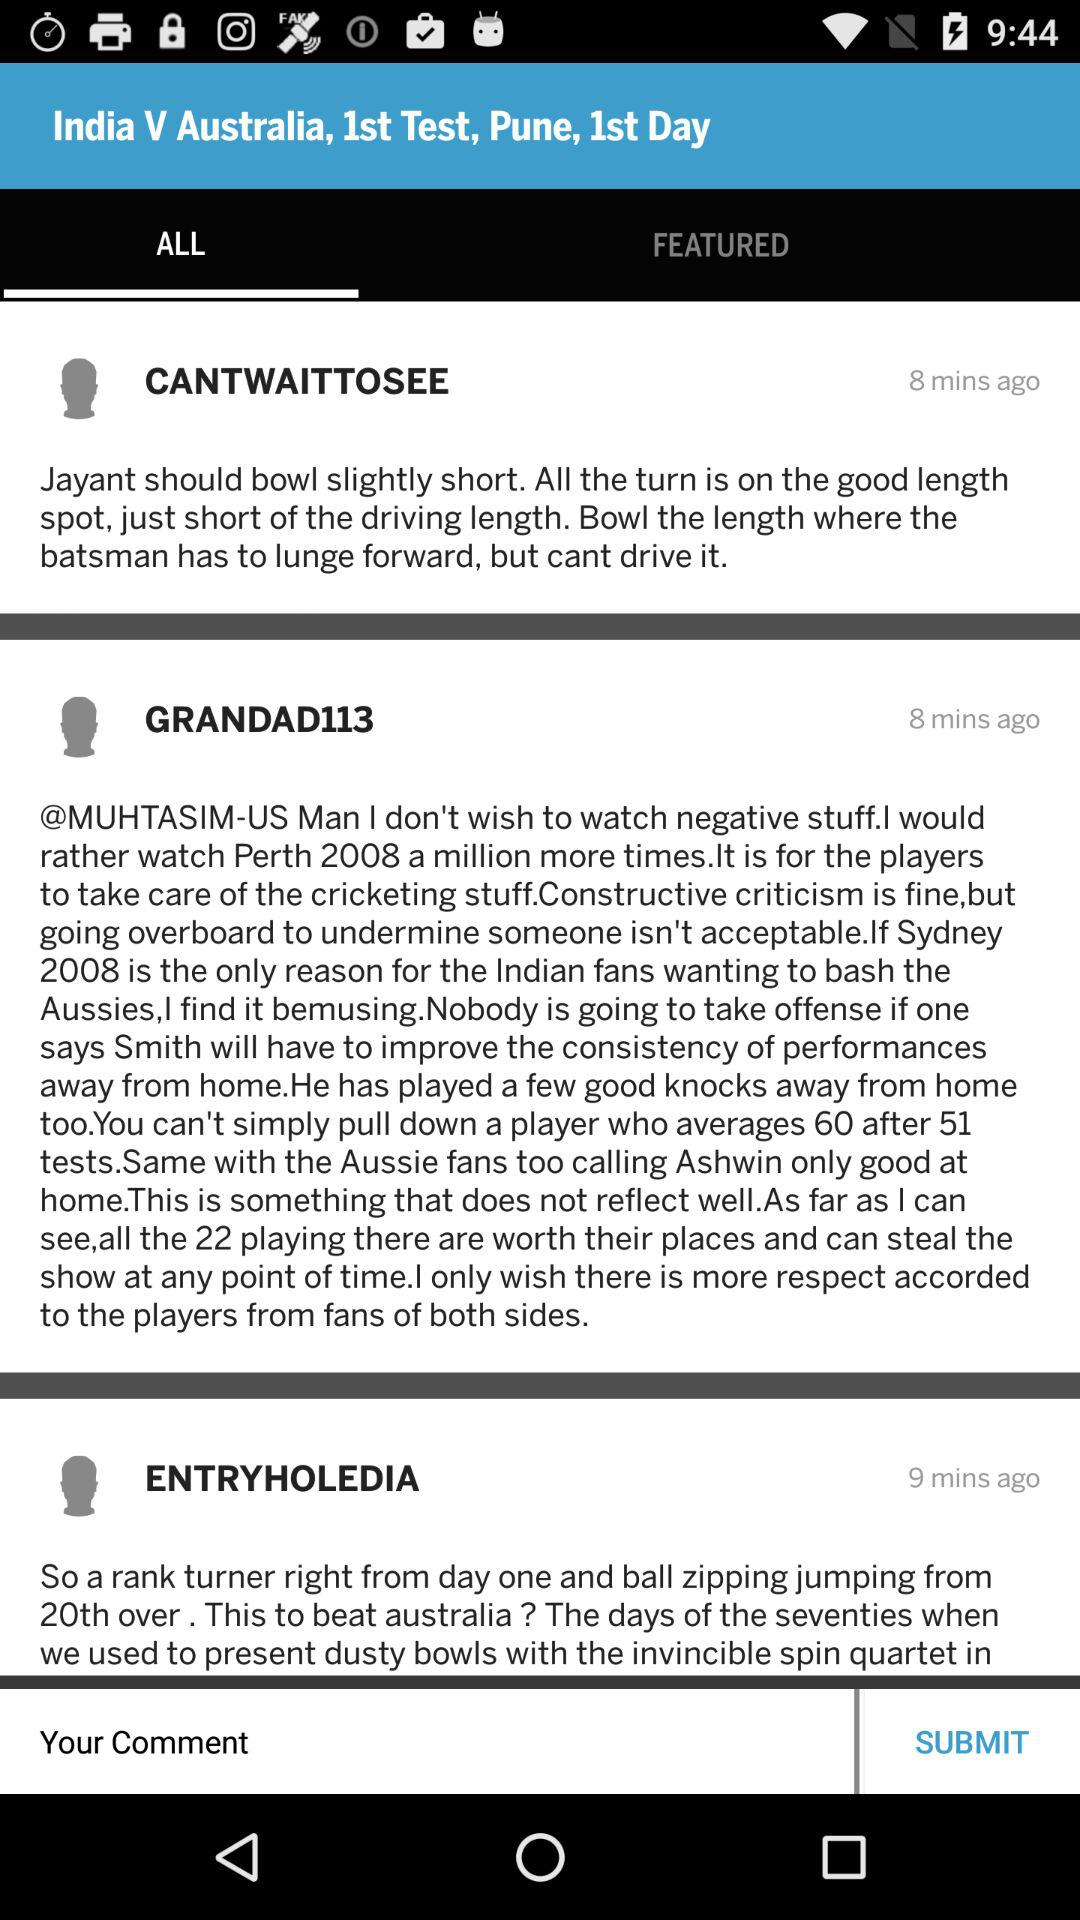How many minutes ago was the article "CANTWAITTOSEE" posted? The article was posted 8 minutes ago. 